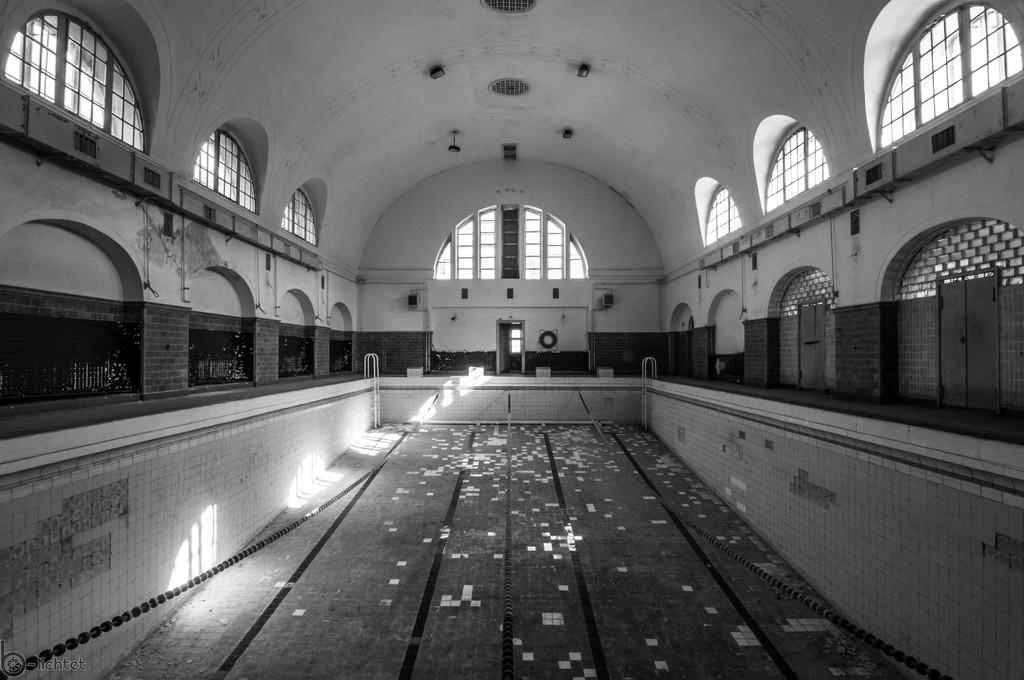What is the condition of the swimming pool in the image? The swimming pool in the image does not have water in it. What can be seen in the background of the image? There is a wall in the background of the image. Where are the doors located in the image? The doors are on the right side of the image. What type of leaf is being used as a bookmark by the daughter in the image? There is no daughter or leaf present in the image. Can you tell me how many horses are visible in the image? There are no horses visible in the image. 